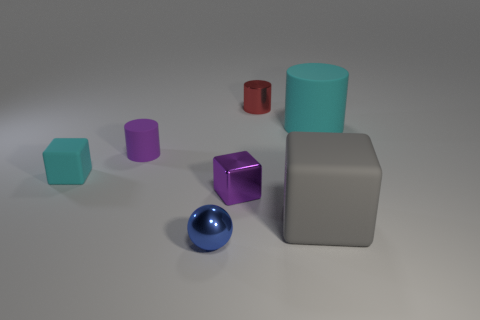Subtract all tiny cubes. How many cubes are left? 1 Subtract all purple cylinders. How many cylinders are left? 2 Subtract 3 cubes. How many cubes are left? 0 Add 3 brown cylinders. How many objects exist? 10 Subtract all blocks. How many objects are left? 4 Subtract all green spheres. How many blue cylinders are left? 0 Subtract 0 gray cylinders. How many objects are left? 7 Subtract all gray cylinders. Subtract all red spheres. How many cylinders are left? 3 Subtract all big red spheres. Subtract all cyan rubber things. How many objects are left? 5 Add 7 metallic things. How many metallic things are left? 10 